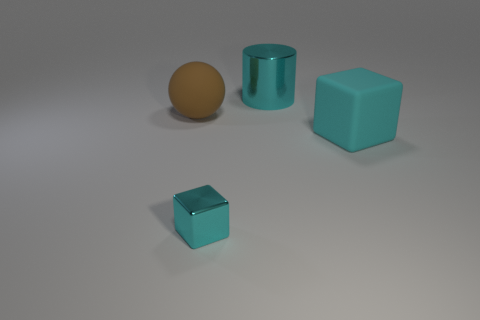There is a big cyan thing behind the big brown thing behind the tiny metal thing; what is its material?
Offer a very short reply. Metal. There is a block that is right of the big metal cylinder; is it the same color as the small block?
Your response must be concise. Yes. Are there any other things that have the same material as the large brown thing?
Make the answer very short. Yes. How many big cyan objects have the same shape as the brown thing?
Give a very brief answer. 0. There is a cyan block that is made of the same material as the large cylinder; what is its size?
Keep it short and to the point. Small. There is a metal thing that is behind the cyan metallic thing on the left side of the large cylinder; are there any big shiny cylinders that are in front of it?
Your response must be concise. No. Does the matte object in front of the brown rubber ball have the same size as the cylinder?
Offer a very short reply. Yes. How many matte cubes are the same size as the cylinder?
Give a very brief answer. 1. The metallic thing that is the same color as the shiny cylinder is what size?
Your response must be concise. Small. Does the small shiny thing have the same color as the large metal cylinder?
Your response must be concise. Yes. 